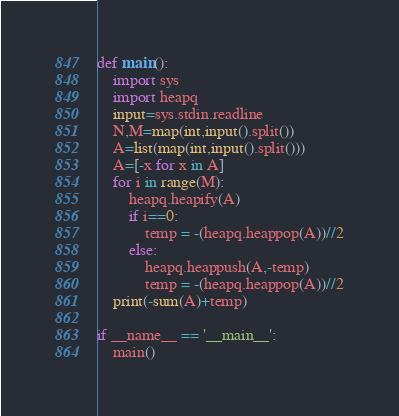Convert code to text. <code><loc_0><loc_0><loc_500><loc_500><_Python_>def main():
    import sys
    import heapq
    input=sys.stdin.readline
    N,M=map(int,input().split())
    A=list(map(int,input().split()))
    A=[-x for x in A]
    for i in range(M):
        heapq.heapify(A)
        if i==0:
            temp = -(heapq.heappop(A))//2
        else:
            heapq.heappush(A,-temp)
            temp = -(heapq.heappop(A))//2
    print(-sum(A)+temp)
    
if __name__ == '__main__':
    main()</code> 